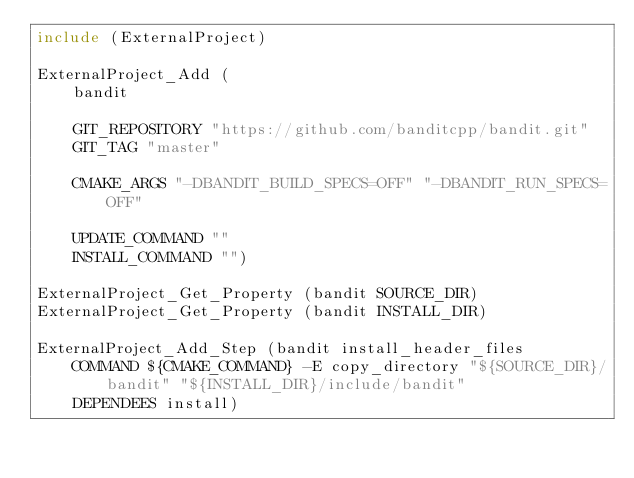<code> <loc_0><loc_0><loc_500><loc_500><_CMake_>include (ExternalProject)

ExternalProject_Add (
    bandit

    GIT_REPOSITORY "https://github.com/banditcpp/bandit.git"
    GIT_TAG "master"
    
    CMAKE_ARGS "-DBANDIT_BUILD_SPECS=OFF" "-DBANDIT_RUN_SPECS=OFF"
      
    UPDATE_COMMAND ""
    INSTALL_COMMAND "")

ExternalProject_Get_Property (bandit SOURCE_DIR)
ExternalProject_Get_Property (bandit INSTALL_DIR)

ExternalProject_Add_Step (bandit install_header_files
    COMMAND ${CMAKE_COMMAND} -E copy_directory "${SOURCE_DIR}/bandit" "${INSTALL_DIR}/include/bandit"
    DEPENDEES install)
</code> 